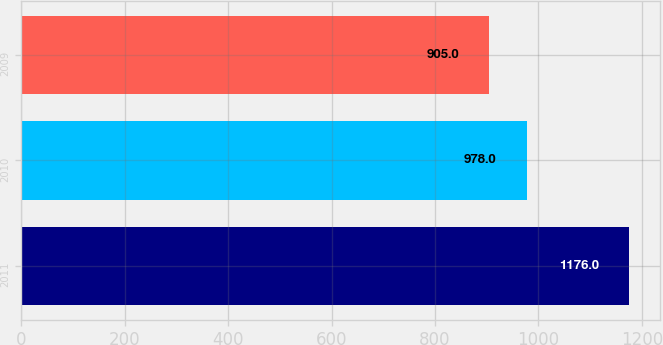Convert chart to OTSL. <chart><loc_0><loc_0><loc_500><loc_500><bar_chart><fcel>2011<fcel>2010<fcel>2009<nl><fcel>1176<fcel>978<fcel>905<nl></chart> 